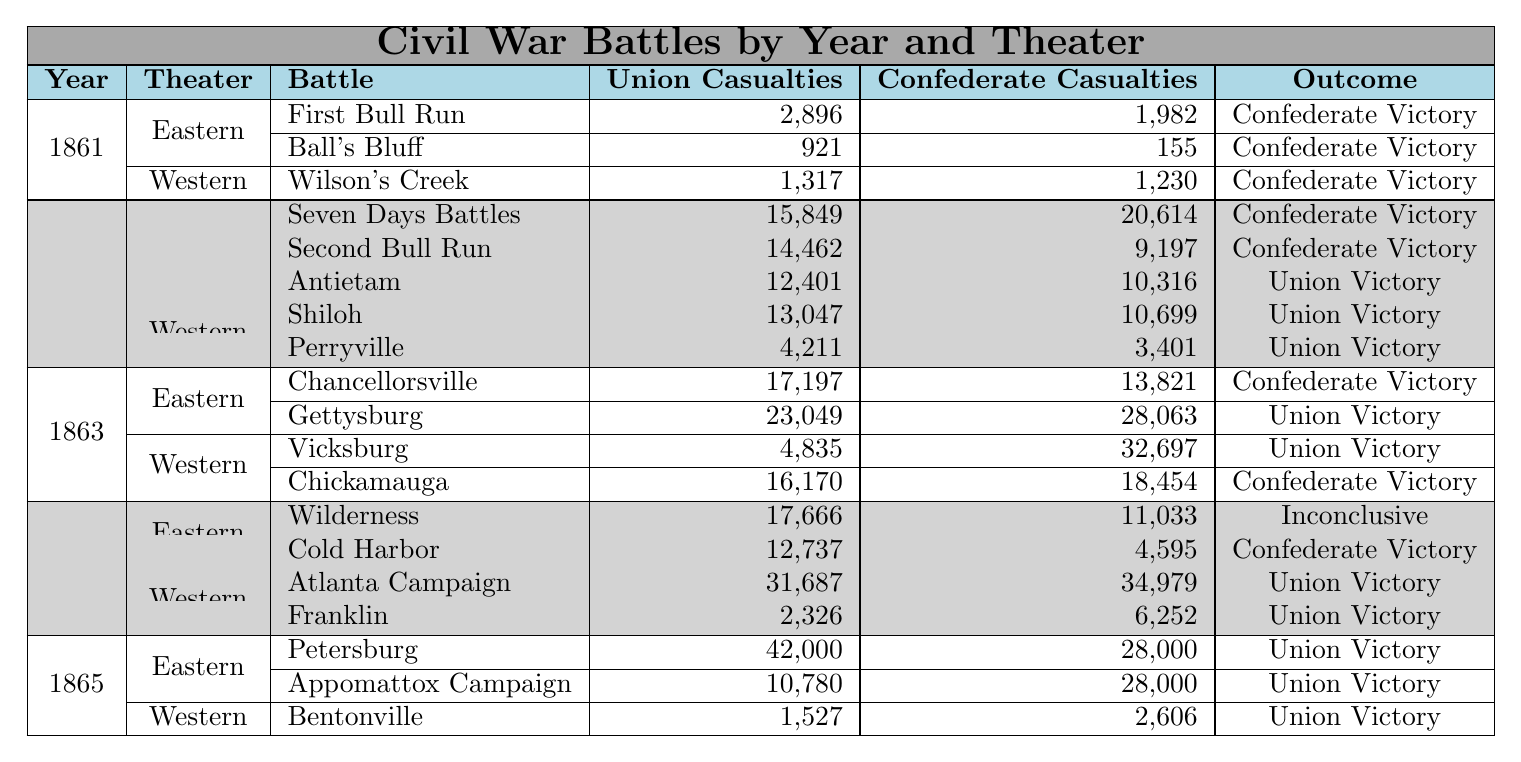What was the outcome of the Battle of Gettysburg? The Battle of Gettysburg is listed under the Eastern Theater in 1863, and its outcome is stated as "Union Victory."
Answer: Union Victory How many total Union casualties were there in 1862? To find the total Union casualties in 1862, we add the casualties from each battle: 15849 (Seven Days) + 14462 (Second Bull Run) + 12401 (Antietam) + 13047 (Shiloh) + 4211 (Perryville) = 70870.
Answer: 70870 What was the highest number of Confederate casualties in a single battle listed in the table? The highest number of Confederate casualties occurs in the Battle of Chickamauga with 18454. This can be found by reviewing the casualties for each battle in the table.
Answer: 18454 Did the Union win more battles than the Confederates in 1865? In 1865, the Union won 3 battles (Petersburg, Appomattox Campaign, and Bentonville) while the Confederates did not win any. Therefore, the answer is yes.
Answer: Yes Which battle had the most significant difference in Union and Confederate casualties in favor of the Union? The Petersburg battle in 1865 had a Union casualty of 42000 and a Confederate casualty of 28000. The difference is 42000 - 28000 = 14000, which is the largest difference favoring the Union.
Answer: Petersburg What was the total number of battles in the Western Theater in 1863? In the Western Theater for the year 1863, there are two battles listed: Vicksburg and Chickamauga. Thus, the answer is 2.
Answer: 2 What year had more battles that resulted in Confederate victories than Union victories? In 1861, all battles listed (First Bull Run, Ball’s Bluff, Wilson’s Creek) resulted in Confederate victories. During other years (like 1862-1864), there were some Union victories as well. Therefore, 1861 fits this criterion.
Answer: 1861 How many battles in the Eastern Theater ended with an inconclusive outcome? The table shows only one battle with an inconclusive outcome: Wilderness in 1864.
Answer: 1 Which year had the highest total Union casualties across all battles listed? The year with the highest total Union casualties can be calculated: 1864 (total = 17666 + 12737 + 31687 + 2326 = 61916) versus 1865 (total = 42000 + 10780 + 1527 = 54207). 1864 has the highest total of 61916.
Answer: 1864 Was the average number of Union casualties in the battles of 1863 more than in 1861? The average in 1861 is (2896 + 921 + 1317) / 3 = 1384.67 and in 1863 is (17197 + 23049 + 4835 + 16170) / 4 = 14377.75. Since 14377.75 is greater than 1384.67, we conclude that it was.
Answer: Yes 